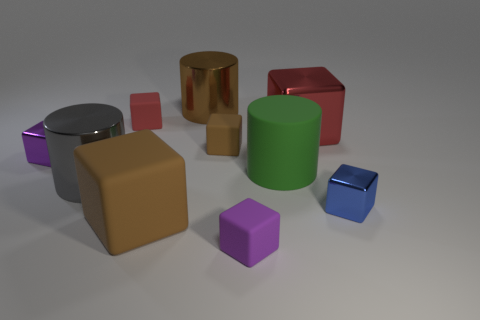There is a red thing on the right side of the purple object that is right of the brown metal thing; how big is it?
Make the answer very short. Large. What number of other objects are the same size as the brown metallic cylinder?
Give a very brief answer. 4. How many metal cylinders are on the left side of the red shiny cube?
Provide a succinct answer. 2. The green object is what size?
Offer a terse response. Large. Is the material of the red cube to the right of the small red rubber object the same as the big brown block in front of the gray metal thing?
Keep it short and to the point. No. Are there any metallic blocks of the same color as the big rubber block?
Your answer should be very brief. No. What color is the matte block that is the same size as the rubber cylinder?
Your answer should be compact. Brown. Does the big rubber thing that is behind the big gray shiny object have the same color as the big rubber block?
Your answer should be very brief. No. Are there any blue objects that have the same material as the tiny red block?
Ensure brevity in your answer.  No. What shape is the small rubber object that is the same color as the big rubber block?
Your answer should be very brief. Cube. 